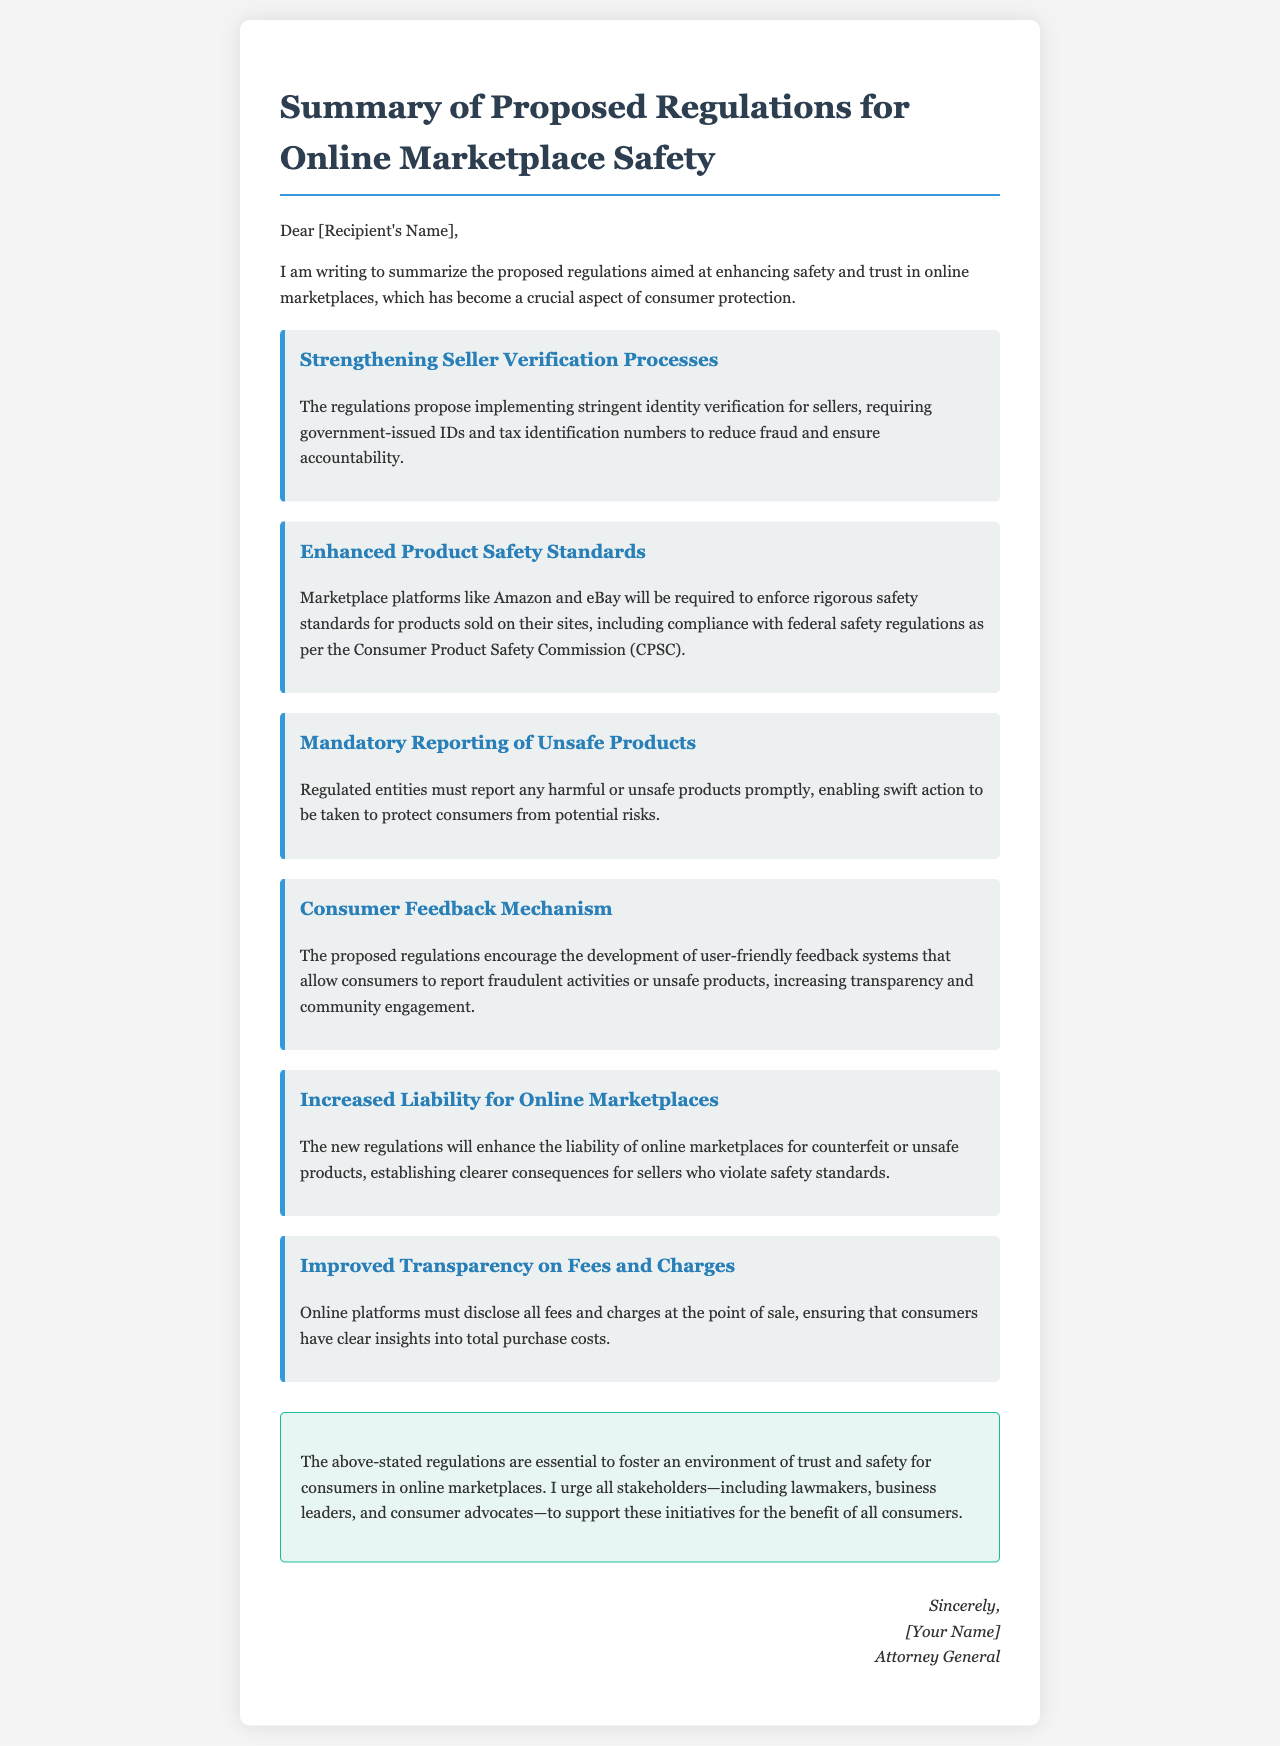What is the main goal of the proposed regulations? The main goal of the proposed regulations is to enhance safety and trust in online marketplaces.
Answer: Enhance safety and trust Who must report any harmful or unsafe products? Regulated entities are required to report any harmful or unsafe products.
Answer: Regulated entities What is required for seller verification? The regulations require government-issued IDs and tax identification numbers for seller verification.
Answer: Government-issued IDs and tax identification numbers Which commission's safety regulations must be complied with? The proposed regulations require compliance with federal safety regulations as per the Consumer Product Safety Commission.
Answer: Consumer Product Safety Commission What must online platforms disclose at the point of sale? Online platforms must disclose all fees and charges at the point of sale.
Answer: All fees and charges How will the new regulations affect liability for online marketplaces? The new regulations will enhance the liability of online marketplaces for counterfeit or unsafe products.
Answer: Enhance liability What feedback system is encouraged by the proposed regulations? The proposed regulations encourage the development of user-friendly feedback systems for reporting fraudulent activities or unsafe products.
Answer: User-friendly feedback systems Who is urged to support these initiatives? All stakeholders including lawmakers, business leaders, and consumer advocates are urged to support these initiatives.
Answer: All stakeholders What color is the signature section? The signature section is styled in an italic font and is aligned to the right.
Answer: Italic font and right-aligned 